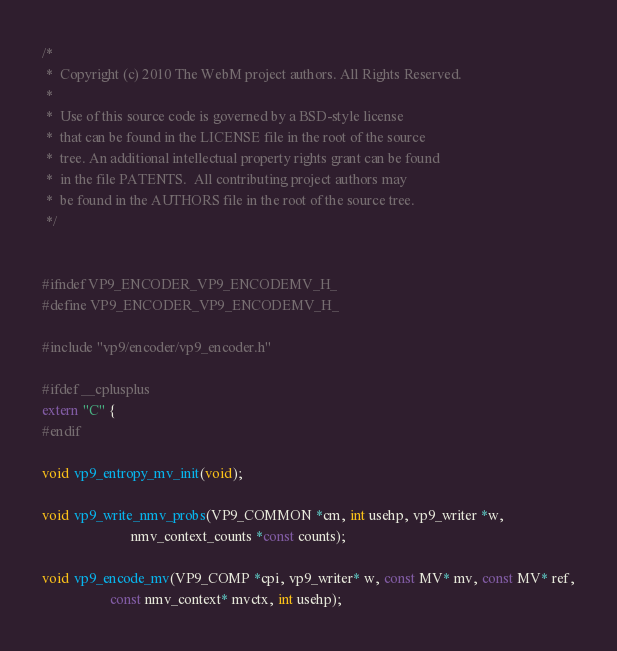Convert code to text. <code><loc_0><loc_0><loc_500><loc_500><_C_>/*
 *  Copyright (c) 2010 The WebM project authors. All Rights Reserved.
 *
 *  Use of this source code is governed by a BSD-style license
 *  that can be found in the LICENSE file in the root of the source
 *  tree. An additional intellectual property rights grant can be found
 *  in the file PATENTS.  All contributing project authors may
 *  be found in the AUTHORS file in the root of the source tree.
 */


#ifndef VP9_ENCODER_VP9_ENCODEMV_H_
#define VP9_ENCODER_VP9_ENCODEMV_H_

#include "vp9/encoder/vp9_encoder.h"

#ifdef __cplusplus
extern "C" {
#endif

void vp9_entropy_mv_init(void);

void vp9_write_nmv_probs(VP9_COMMON *cm, int usehp, vp9_writer *w,
                         nmv_context_counts *const counts);

void vp9_encode_mv(VP9_COMP *cpi, vp9_writer* w, const MV* mv, const MV* ref,
                   const nmv_context* mvctx, int usehp);
</code> 